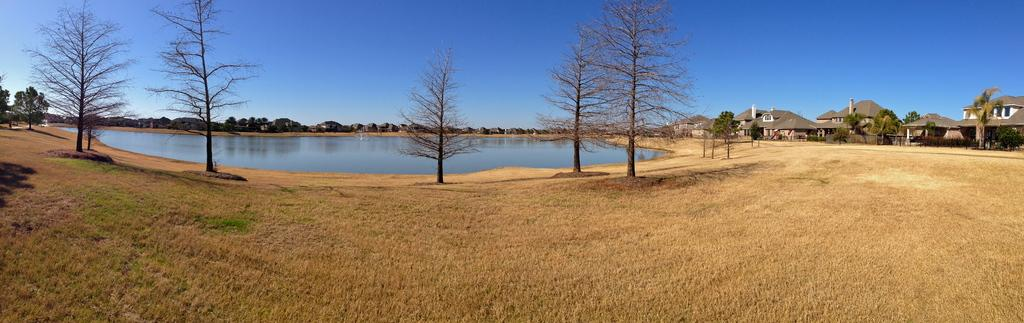What type of vegetation is in the front of the image? There is dry grass in the front of the image. What can be seen in the center of the image? There are trees in the center of the image. What type of structures are present in the image? There are buildings in the image. What is visible in the background of the image? There is water and trees visible in the background of the image. Is there a jail visible in the image? There is no mention of a jail in the provided facts, and therefore it cannot be determined if one is present in the image. What type of pollution can be seen in the image? There is no mention of pollution in the provided facts, and therefore it cannot be determined if any is present in the image. 